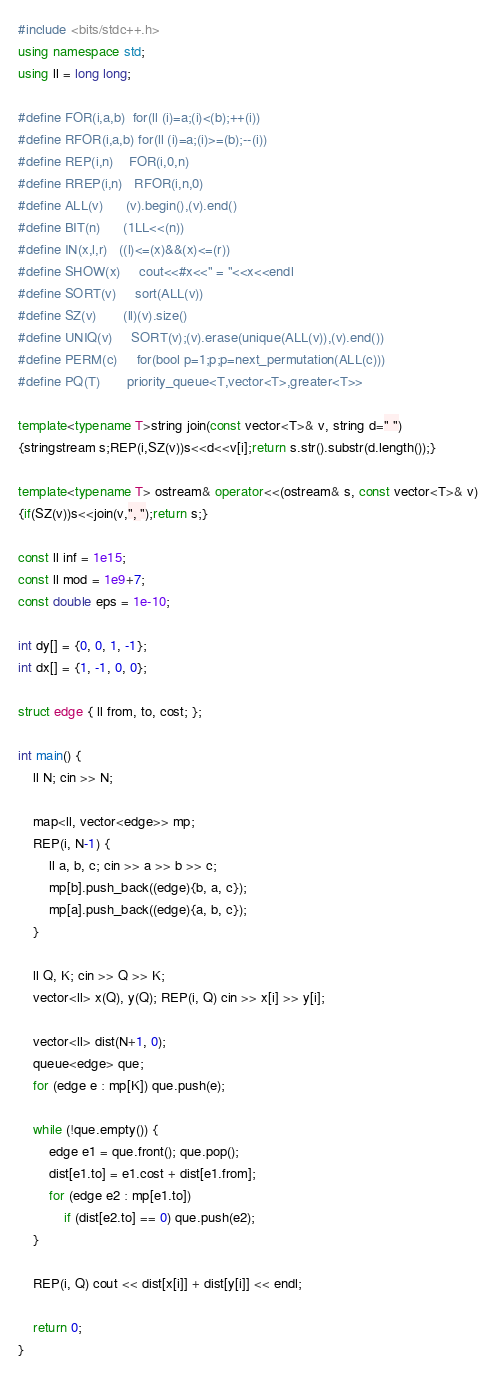<code> <loc_0><loc_0><loc_500><loc_500><_C++_>#include <bits/stdc++.h>
using namespace std;
using ll = long long;

#define FOR(i,a,b)  for(ll (i)=a;(i)<(b);++(i))
#define RFOR(i,a,b) for(ll (i)=a;(i)>=(b);--(i))
#define REP(i,n)    FOR(i,0,n)
#define RREP(i,n)   RFOR(i,n,0)
#define ALL(v)      (v).begin(),(v).end()
#define BIT(n)      (1LL<<(n))
#define IN(x,l,r)   ((l)<=(x)&&(x)<=(r))
#define SHOW(x)     cout<<#x<<" = "<<x<<endl
#define SORT(v)     sort(ALL(v))
#define SZ(v)       (ll)(v).size()
#define UNIQ(v)     SORT(v);(v).erase(unique(ALL(v)),(v).end())
#define PERM(c)     for(bool p=1;p;p=next_permutation(ALL(c)))
#define PQ(T)       priority_queue<T,vector<T>,greater<T>>

template<typename T>string join(const vector<T>& v, string d=" ")
{stringstream s;REP(i,SZ(v))s<<d<<v[i];return s.str().substr(d.length());}

template<typename T> ostream& operator<<(ostream& s, const vector<T>& v)
{if(SZ(v))s<<join(v,", ");return s;}

const ll inf = 1e15;
const ll mod = 1e9+7;
const double eps = 1e-10;

int dy[] = {0, 0, 1, -1};
int dx[] = {1, -1, 0, 0};

struct edge { ll from, to, cost; };

int main() {
    ll N; cin >> N;
    
    map<ll, vector<edge>> mp;
    REP(i, N-1) {
        ll a, b, c; cin >> a >> b >> c;
        mp[b].push_back((edge){b, a, c});
        mp[a].push_back((edge){a, b, c});
    }
    
    ll Q, K; cin >> Q >> K;
    vector<ll> x(Q), y(Q); REP(i, Q) cin >> x[i] >> y[i];
    
    vector<ll> dist(N+1, 0);
    queue<edge> que;
    for (edge e : mp[K]) que.push(e);
    
    while (!que.empty()) {
        edge e1 = que.front(); que.pop();
        dist[e1.to] = e1.cost + dist[e1.from];
        for (edge e2 : mp[e1.to]) 
            if (dist[e2.to] == 0) que.push(e2);
    }
    
    REP(i, Q) cout << dist[x[i]] + dist[y[i]] << endl;
    
    return 0;
}
</code> 